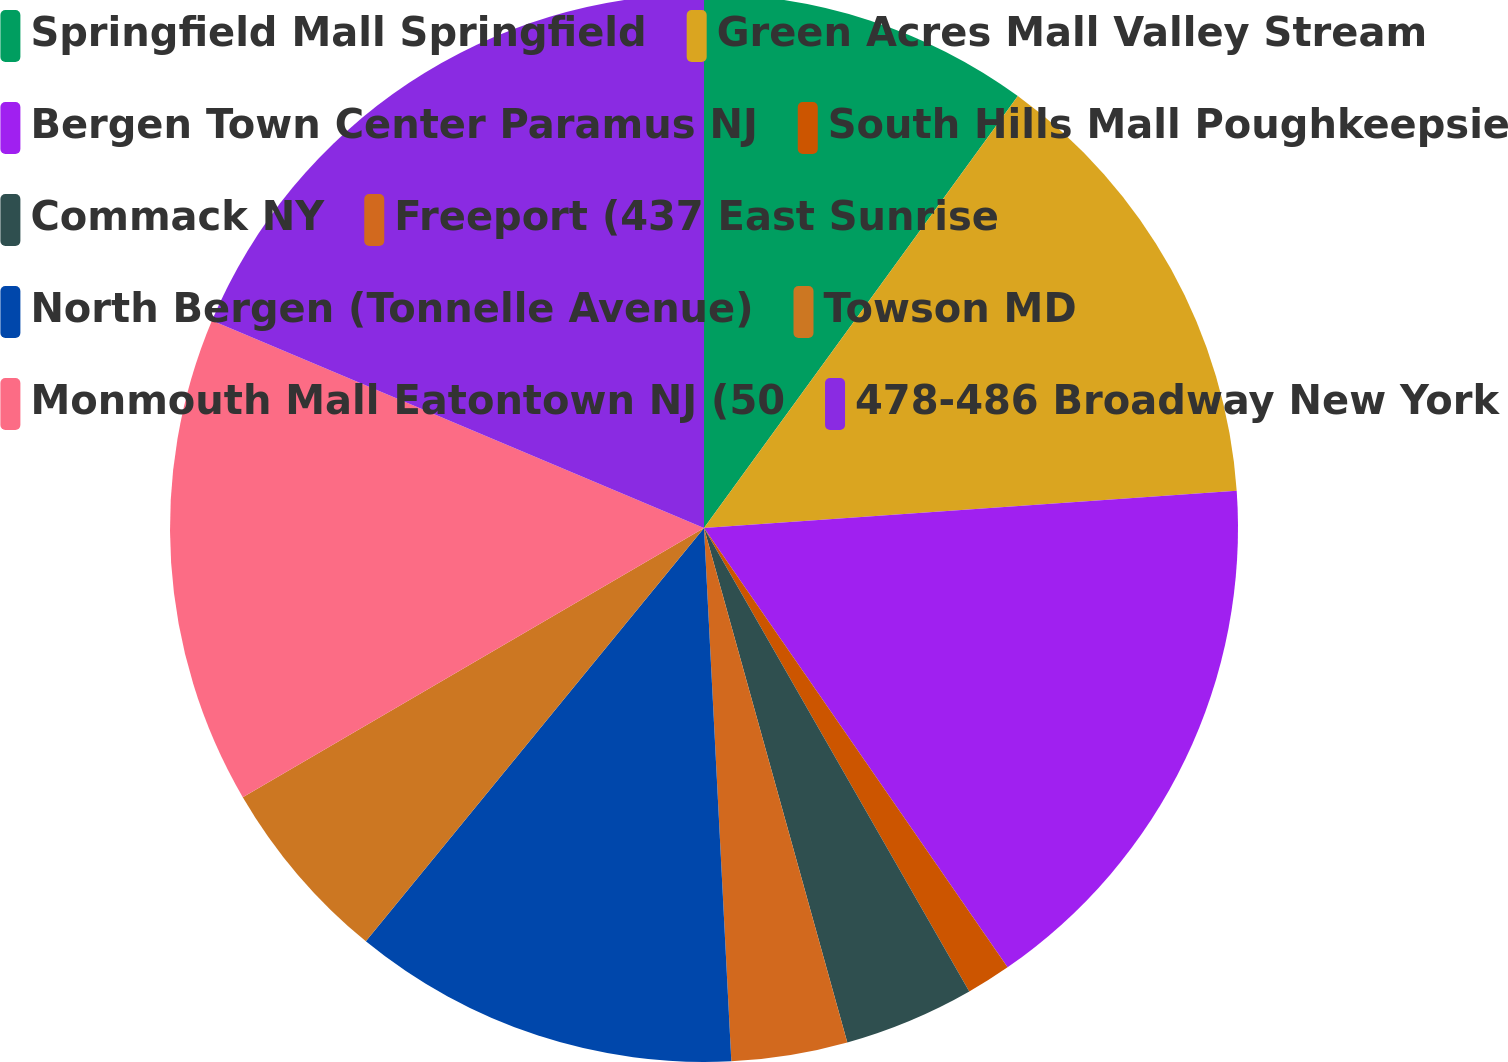Convert chart to OTSL. <chart><loc_0><loc_0><loc_500><loc_500><pie_chart><fcel>Springfield Mall Springfield<fcel>Green Acres Mall Valley Stream<fcel>Bergen Town Center Paramus NJ<fcel>South Hills Mall Poughkeepsie<fcel>Commack NY<fcel>Freeport (437 East Sunrise<fcel>North Bergen (Tonnelle Avenue)<fcel>Towson MD<fcel>Monmouth Mall Eatontown NJ (50<fcel>478-486 Broadway New York<nl><fcel>10.0%<fcel>13.89%<fcel>16.49%<fcel>1.35%<fcel>3.95%<fcel>3.51%<fcel>11.73%<fcel>5.68%<fcel>14.76%<fcel>18.65%<nl></chart> 